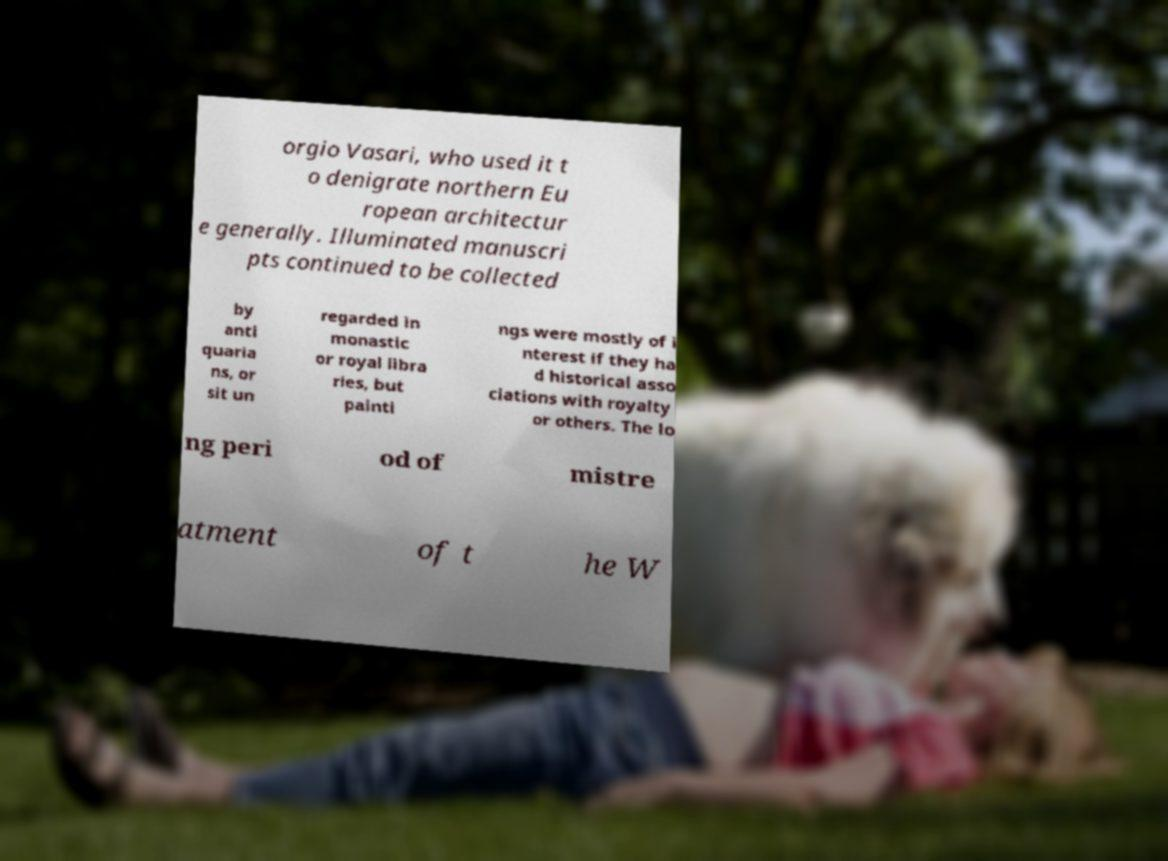Could you assist in decoding the text presented in this image and type it out clearly? orgio Vasari, who used it t o denigrate northern Eu ropean architectur e generally. Illuminated manuscri pts continued to be collected by anti quaria ns, or sit un regarded in monastic or royal libra ries, but painti ngs were mostly of i nterest if they ha d historical asso ciations with royalty or others. The lo ng peri od of mistre atment of t he W 